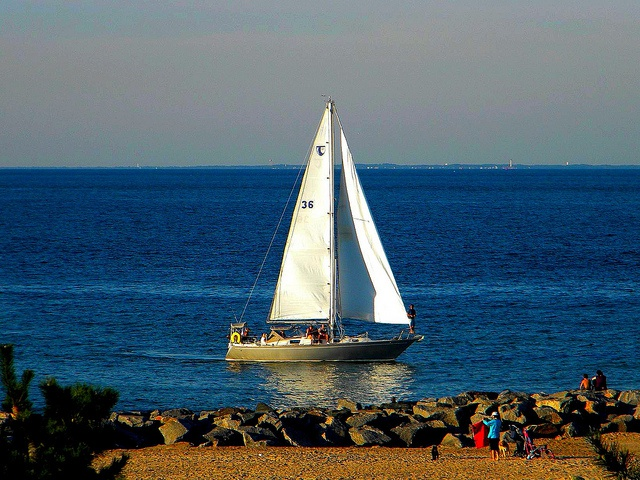Describe the objects in this image and their specific colors. I can see boat in gray, ivory, blue, and black tones, people in gray, black, navy, teal, and maroon tones, people in gray, black, navy, maroon, and blue tones, people in gray, black, navy, maroon, and brown tones, and people in gray, black, maroon, and brown tones in this image. 